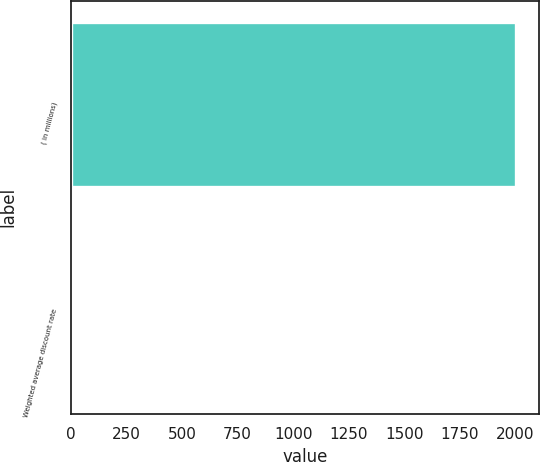Convert chart to OTSL. <chart><loc_0><loc_0><loc_500><loc_500><bar_chart><fcel>( in millions)<fcel>Weighted average discount rate<nl><fcel>2006<fcel>6<nl></chart> 